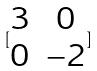Convert formula to latex. <formula><loc_0><loc_0><loc_500><loc_500>[ \begin{matrix} 3 & 0 \\ 0 & - 2 \end{matrix} ]</formula> 